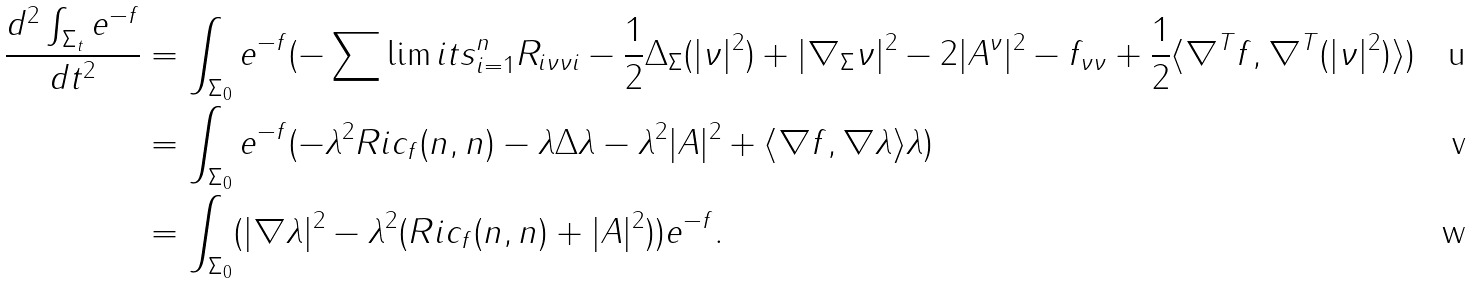Convert formula to latex. <formula><loc_0><loc_0><loc_500><loc_500>\frac { d ^ { 2 } \int _ { \Sigma _ { t } } e ^ { - f } } { d t ^ { 2 } } & = \int _ { \Sigma _ { 0 } } e ^ { - f } ( - \sum \lim i t s _ { i = 1 } ^ { n } R _ { i \nu \nu i } - \frac { 1 } { 2 } \Delta _ { \Sigma } ( | \nu | ^ { 2 } ) + | \nabla _ { \Sigma } \nu | ^ { 2 } - 2 | A ^ { \nu } | ^ { 2 } - f _ { \nu \nu } + \frac { 1 } { 2 } \langle \nabla ^ { T } f , \nabla ^ { T } ( | \nu | ^ { 2 } ) \rangle ) \\ & = \int _ { \Sigma _ { 0 } } e ^ { - f } ( - \lambda ^ { 2 } R i c _ { f } ( n , n ) - \lambda \Delta \lambda - \lambda ^ { 2 } | A | ^ { 2 } + \langle \nabla f , \nabla \lambda \rangle \lambda ) \\ & = \int _ { \Sigma _ { 0 } } ( | \nabla \lambda | ^ { 2 } - \lambda ^ { 2 } ( R i c _ { f } ( n , n ) + | A | ^ { 2 } ) ) e ^ { - f } .</formula> 